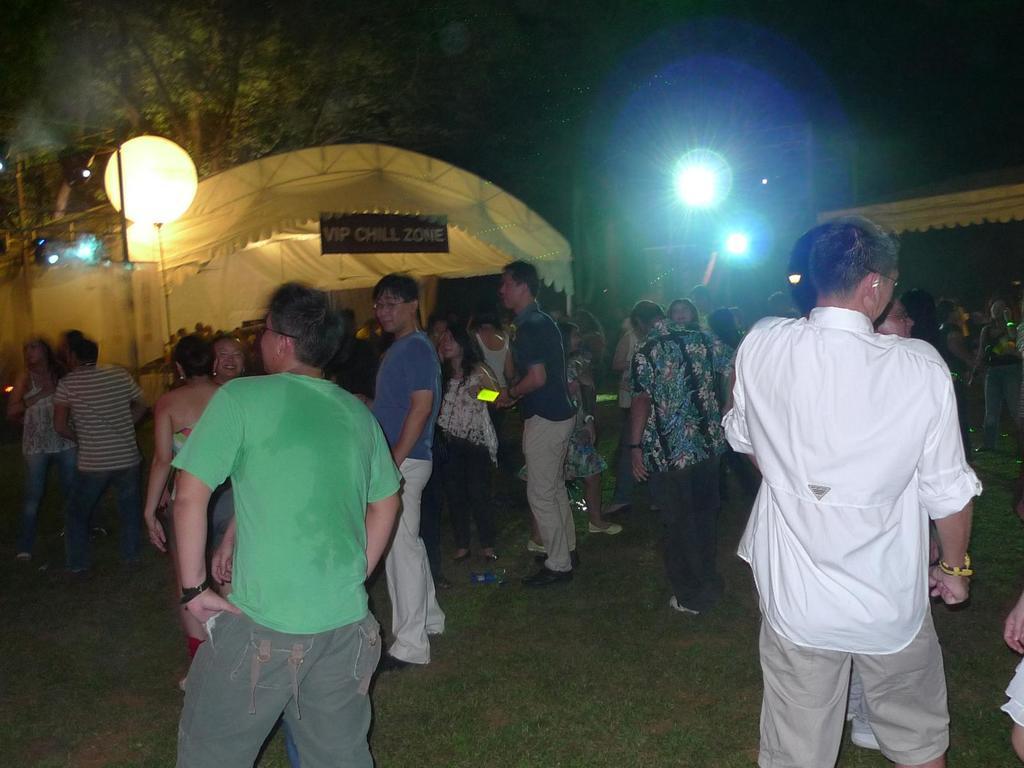Could you give a brief overview of what you see in this image? In the given image i can see the lights,people,sheds,grass and trees. 